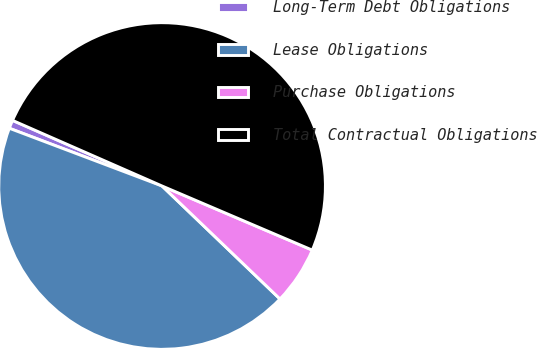<chart> <loc_0><loc_0><loc_500><loc_500><pie_chart><fcel>Long-Term Debt Obligations<fcel>Lease Obligations<fcel>Purchase Obligations<fcel>Total Contractual Obligations<nl><fcel>0.83%<fcel>43.59%<fcel>5.74%<fcel>49.84%<nl></chart> 